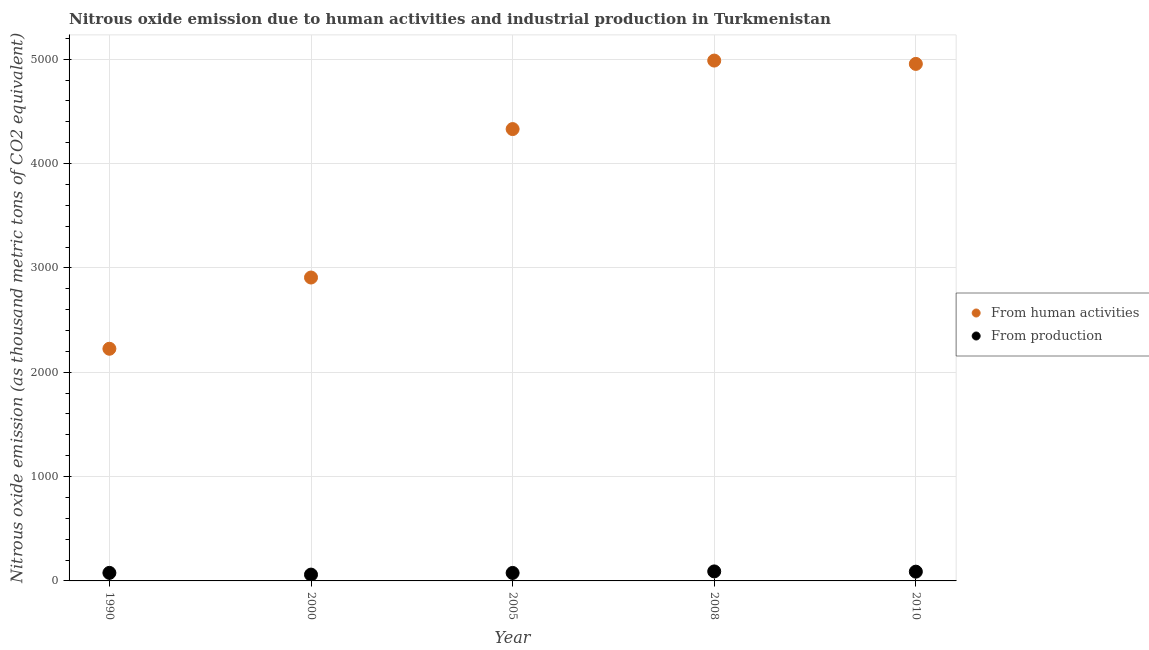How many different coloured dotlines are there?
Provide a short and direct response. 2. Is the number of dotlines equal to the number of legend labels?
Offer a terse response. Yes. What is the amount of emissions from human activities in 2010?
Give a very brief answer. 4955.2. Across all years, what is the maximum amount of emissions generated from industries?
Ensure brevity in your answer.  91.1. Across all years, what is the minimum amount of emissions from human activities?
Your answer should be compact. 2225.1. In which year was the amount of emissions generated from industries maximum?
Make the answer very short. 2008. What is the total amount of emissions from human activities in the graph?
Make the answer very short. 1.94e+04. What is the difference between the amount of emissions from human activities in 2000 and that in 2010?
Offer a very short reply. -2047.3. What is the difference between the amount of emissions generated from industries in 2008 and the amount of emissions from human activities in 2005?
Provide a short and direct response. -4239.5. What is the average amount of emissions from human activities per year?
Keep it short and to the point. 3881.18. In the year 1990, what is the difference between the amount of emissions generated from industries and amount of emissions from human activities?
Your response must be concise. -2148. In how many years, is the amount of emissions generated from industries greater than 800 thousand metric tons?
Provide a succinct answer. 0. What is the ratio of the amount of emissions generated from industries in 2000 to that in 2005?
Your answer should be very brief. 0.79. Is the amount of emissions generated from industries in 1990 less than that in 2005?
Offer a terse response. No. What is the difference between the highest and the second highest amount of emissions generated from industries?
Make the answer very short. 2.4. What is the difference between the highest and the lowest amount of emissions from human activities?
Give a very brief answer. 2762. In how many years, is the amount of emissions from human activities greater than the average amount of emissions from human activities taken over all years?
Your answer should be very brief. 3. Is the sum of the amount of emissions from human activities in 1990 and 2005 greater than the maximum amount of emissions generated from industries across all years?
Provide a short and direct response. Yes. Does the amount of emissions generated from industries monotonically increase over the years?
Make the answer very short. No. Is the amount of emissions generated from industries strictly greater than the amount of emissions from human activities over the years?
Offer a very short reply. No. How many years are there in the graph?
Your answer should be compact. 5. What is the difference between two consecutive major ticks on the Y-axis?
Keep it short and to the point. 1000. Are the values on the major ticks of Y-axis written in scientific E-notation?
Your answer should be very brief. No. What is the title of the graph?
Your answer should be very brief. Nitrous oxide emission due to human activities and industrial production in Turkmenistan. Does "RDB nonconcessional" appear as one of the legend labels in the graph?
Provide a short and direct response. No. What is the label or title of the X-axis?
Provide a succinct answer. Year. What is the label or title of the Y-axis?
Offer a terse response. Nitrous oxide emission (as thousand metric tons of CO2 equivalent). What is the Nitrous oxide emission (as thousand metric tons of CO2 equivalent) in From human activities in 1990?
Make the answer very short. 2225.1. What is the Nitrous oxide emission (as thousand metric tons of CO2 equivalent) in From production in 1990?
Provide a succinct answer. 77.1. What is the Nitrous oxide emission (as thousand metric tons of CO2 equivalent) of From human activities in 2000?
Ensure brevity in your answer.  2907.9. What is the Nitrous oxide emission (as thousand metric tons of CO2 equivalent) of From production in 2000?
Ensure brevity in your answer.  60.5. What is the Nitrous oxide emission (as thousand metric tons of CO2 equivalent) of From human activities in 2005?
Provide a short and direct response. 4330.6. What is the Nitrous oxide emission (as thousand metric tons of CO2 equivalent) in From production in 2005?
Your answer should be compact. 76.5. What is the Nitrous oxide emission (as thousand metric tons of CO2 equivalent) in From human activities in 2008?
Offer a very short reply. 4987.1. What is the Nitrous oxide emission (as thousand metric tons of CO2 equivalent) in From production in 2008?
Provide a succinct answer. 91.1. What is the Nitrous oxide emission (as thousand metric tons of CO2 equivalent) in From human activities in 2010?
Make the answer very short. 4955.2. What is the Nitrous oxide emission (as thousand metric tons of CO2 equivalent) in From production in 2010?
Offer a very short reply. 88.7. Across all years, what is the maximum Nitrous oxide emission (as thousand metric tons of CO2 equivalent) in From human activities?
Provide a succinct answer. 4987.1. Across all years, what is the maximum Nitrous oxide emission (as thousand metric tons of CO2 equivalent) of From production?
Provide a short and direct response. 91.1. Across all years, what is the minimum Nitrous oxide emission (as thousand metric tons of CO2 equivalent) of From human activities?
Ensure brevity in your answer.  2225.1. Across all years, what is the minimum Nitrous oxide emission (as thousand metric tons of CO2 equivalent) in From production?
Your answer should be very brief. 60.5. What is the total Nitrous oxide emission (as thousand metric tons of CO2 equivalent) in From human activities in the graph?
Keep it short and to the point. 1.94e+04. What is the total Nitrous oxide emission (as thousand metric tons of CO2 equivalent) of From production in the graph?
Your response must be concise. 393.9. What is the difference between the Nitrous oxide emission (as thousand metric tons of CO2 equivalent) in From human activities in 1990 and that in 2000?
Make the answer very short. -682.8. What is the difference between the Nitrous oxide emission (as thousand metric tons of CO2 equivalent) in From production in 1990 and that in 2000?
Keep it short and to the point. 16.6. What is the difference between the Nitrous oxide emission (as thousand metric tons of CO2 equivalent) of From human activities in 1990 and that in 2005?
Offer a very short reply. -2105.5. What is the difference between the Nitrous oxide emission (as thousand metric tons of CO2 equivalent) in From production in 1990 and that in 2005?
Your answer should be compact. 0.6. What is the difference between the Nitrous oxide emission (as thousand metric tons of CO2 equivalent) of From human activities in 1990 and that in 2008?
Your response must be concise. -2762. What is the difference between the Nitrous oxide emission (as thousand metric tons of CO2 equivalent) in From human activities in 1990 and that in 2010?
Provide a short and direct response. -2730.1. What is the difference between the Nitrous oxide emission (as thousand metric tons of CO2 equivalent) of From human activities in 2000 and that in 2005?
Give a very brief answer. -1422.7. What is the difference between the Nitrous oxide emission (as thousand metric tons of CO2 equivalent) of From human activities in 2000 and that in 2008?
Make the answer very short. -2079.2. What is the difference between the Nitrous oxide emission (as thousand metric tons of CO2 equivalent) of From production in 2000 and that in 2008?
Provide a succinct answer. -30.6. What is the difference between the Nitrous oxide emission (as thousand metric tons of CO2 equivalent) of From human activities in 2000 and that in 2010?
Your answer should be very brief. -2047.3. What is the difference between the Nitrous oxide emission (as thousand metric tons of CO2 equivalent) of From production in 2000 and that in 2010?
Make the answer very short. -28.2. What is the difference between the Nitrous oxide emission (as thousand metric tons of CO2 equivalent) of From human activities in 2005 and that in 2008?
Your response must be concise. -656.5. What is the difference between the Nitrous oxide emission (as thousand metric tons of CO2 equivalent) in From production in 2005 and that in 2008?
Give a very brief answer. -14.6. What is the difference between the Nitrous oxide emission (as thousand metric tons of CO2 equivalent) in From human activities in 2005 and that in 2010?
Offer a very short reply. -624.6. What is the difference between the Nitrous oxide emission (as thousand metric tons of CO2 equivalent) of From production in 2005 and that in 2010?
Your answer should be very brief. -12.2. What is the difference between the Nitrous oxide emission (as thousand metric tons of CO2 equivalent) of From human activities in 2008 and that in 2010?
Keep it short and to the point. 31.9. What is the difference between the Nitrous oxide emission (as thousand metric tons of CO2 equivalent) of From production in 2008 and that in 2010?
Offer a terse response. 2.4. What is the difference between the Nitrous oxide emission (as thousand metric tons of CO2 equivalent) of From human activities in 1990 and the Nitrous oxide emission (as thousand metric tons of CO2 equivalent) of From production in 2000?
Give a very brief answer. 2164.6. What is the difference between the Nitrous oxide emission (as thousand metric tons of CO2 equivalent) in From human activities in 1990 and the Nitrous oxide emission (as thousand metric tons of CO2 equivalent) in From production in 2005?
Make the answer very short. 2148.6. What is the difference between the Nitrous oxide emission (as thousand metric tons of CO2 equivalent) in From human activities in 1990 and the Nitrous oxide emission (as thousand metric tons of CO2 equivalent) in From production in 2008?
Provide a short and direct response. 2134. What is the difference between the Nitrous oxide emission (as thousand metric tons of CO2 equivalent) of From human activities in 1990 and the Nitrous oxide emission (as thousand metric tons of CO2 equivalent) of From production in 2010?
Provide a short and direct response. 2136.4. What is the difference between the Nitrous oxide emission (as thousand metric tons of CO2 equivalent) of From human activities in 2000 and the Nitrous oxide emission (as thousand metric tons of CO2 equivalent) of From production in 2005?
Keep it short and to the point. 2831.4. What is the difference between the Nitrous oxide emission (as thousand metric tons of CO2 equivalent) in From human activities in 2000 and the Nitrous oxide emission (as thousand metric tons of CO2 equivalent) in From production in 2008?
Offer a terse response. 2816.8. What is the difference between the Nitrous oxide emission (as thousand metric tons of CO2 equivalent) of From human activities in 2000 and the Nitrous oxide emission (as thousand metric tons of CO2 equivalent) of From production in 2010?
Ensure brevity in your answer.  2819.2. What is the difference between the Nitrous oxide emission (as thousand metric tons of CO2 equivalent) in From human activities in 2005 and the Nitrous oxide emission (as thousand metric tons of CO2 equivalent) in From production in 2008?
Your answer should be very brief. 4239.5. What is the difference between the Nitrous oxide emission (as thousand metric tons of CO2 equivalent) of From human activities in 2005 and the Nitrous oxide emission (as thousand metric tons of CO2 equivalent) of From production in 2010?
Provide a short and direct response. 4241.9. What is the difference between the Nitrous oxide emission (as thousand metric tons of CO2 equivalent) of From human activities in 2008 and the Nitrous oxide emission (as thousand metric tons of CO2 equivalent) of From production in 2010?
Provide a short and direct response. 4898.4. What is the average Nitrous oxide emission (as thousand metric tons of CO2 equivalent) in From human activities per year?
Ensure brevity in your answer.  3881.18. What is the average Nitrous oxide emission (as thousand metric tons of CO2 equivalent) in From production per year?
Offer a terse response. 78.78. In the year 1990, what is the difference between the Nitrous oxide emission (as thousand metric tons of CO2 equivalent) in From human activities and Nitrous oxide emission (as thousand metric tons of CO2 equivalent) in From production?
Keep it short and to the point. 2148. In the year 2000, what is the difference between the Nitrous oxide emission (as thousand metric tons of CO2 equivalent) of From human activities and Nitrous oxide emission (as thousand metric tons of CO2 equivalent) of From production?
Provide a succinct answer. 2847.4. In the year 2005, what is the difference between the Nitrous oxide emission (as thousand metric tons of CO2 equivalent) of From human activities and Nitrous oxide emission (as thousand metric tons of CO2 equivalent) of From production?
Ensure brevity in your answer.  4254.1. In the year 2008, what is the difference between the Nitrous oxide emission (as thousand metric tons of CO2 equivalent) of From human activities and Nitrous oxide emission (as thousand metric tons of CO2 equivalent) of From production?
Your answer should be compact. 4896. In the year 2010, what is the difference between the Nitrous oxide emission (as thousand metric tons of CO2 equivalent) in From human activities and Nitrous oxide emission (as thousand metric tons of CO2 equivalent) in From production?
Your answer should be compact. 4866.5. What is the ratio of the Nitrous oxide emission (as thousand metric tons of CO2 equivalent) of From human activities in 1990 to that in 2000?
Give a very brief answer. 0.77. What is the ratio of the Nitrous oxide emission (as thousand metric tons of CO2 equivalent) of From production in 1990 to that in 2000?
Provide a succinct answer. 1.27. What is the ratio of the Nitrous oxide emission (as thousand metric tons of CO2 equivalent) of From human activities in 1990 to that in 2005?
Offer a very short reply. 0.51. What is the ratio of the Nitrous oxide emission (as thousand metric tons of CO2 equivalent) of From human activities in 1990 to that in 2008?
Make the answer very short. 0.45. What is the ratio of the Nitrous oxide emission (as thousand metric tons of CO2 equivalent) of From production in 1990 to that in 2008?
Ensure brevity in your answer.  0.85. What is the ratio of the Nitrous oxide emission (as thousand metric tons of CO2 equivalent) in From human activities in 1990 to that in 2010?
Give a very brief answer. 0.45. What is the ratio of the Nitrous oxide emission (as thousand metric tons of CO2 equivalent) in From production in 1990 to that in 2010?
Make the answer very short. 0.87. What is the ratio of the Nitrous oxide emission (as thousand metric tons of CO2 equivalent) in From human activities in 2000 to that in 2005?
Your answer should be compact. 0.67. What is the ratio of the Nitrous oxide emission (as thousand metric tons of CO2 equivalent) of From production in 2000 to that in 2005?
Your response must be concise. 0.79. What is the ratio of the Nitrous oxide emission (as thousand metric tons of CO2 equivalent) in From human activities in 2000 to that in 2008?
Your answer should be very brief. 0.58. What is the ratio of the Nitrous oxide emission (as thousand metric tons of CO2 equivalent) in From production in 2000 to that in 2008?
Your answer should be compact. 0.66. What is the ratio of the Nitrous oxide emission (as thousand metric tons of CO2 equivalent) in From human activities in 2000 to that in 2010?
Provide a short and direct response. 0.59. What is the ratio of the Nitrous oxide emission (as thousand metric tons of CO2 equivalent) of From production in 2000 to that in 2010?
Provide a succinct answer. 0.68. What is the ratio of the Nitrous oxide emission (as thousand metric tons of CO2 equivalent) of From human activities in 2005 to that in 2008?
Make the answer very short. 0.87. What is the ratio of the Nitrous oxide emission (as thousand metric tons of CO2 equivalent) of From production in 2005 to that in 2008?
Offer a terse response. 0.84. What is the ratio of the Nitrous oxide emission (as thousand metric tons of CO2 equivalent) in From human activities in 2005 to that in 2010?
Give a very brief answer. 0.87. What is the ratio of the Nitrous oxide emission (as thousand metric tons of CO2 equivalent) in From production in 2005 to that in 2010?
Give a very brief answer. 0.86. What is the ratio of the Nitrous oxide emission (as thousand metric tons of CO2 equivalent) in From human activities in 2008 to that in 2010?
Give a very brief answer. 1.01. What is the ratio of the Nitrous oxide emission (as thousand metric tons of CO2 equivalent) in From production in 2008 to that in 2010?
Ensure brevity in your answer.  1.03. What is the difference between the highest and the second highest Nitrous oxide emission (as thousand metric tons of CO2 equivalent) of From human activities?
Provide a succinct answer. 31.9. What is the difference between the highest and the lowest Nitrous oxide emission (as thousand metric tons of CO2 equivalent) of From human activities?
Offer a very short reply. 2762. What is the difference between the highest and the lowest Nitrous oxide emission (as thousand metric tons of CO2 equivalent) of From production?
Provide a succinct answer. 30.6. 